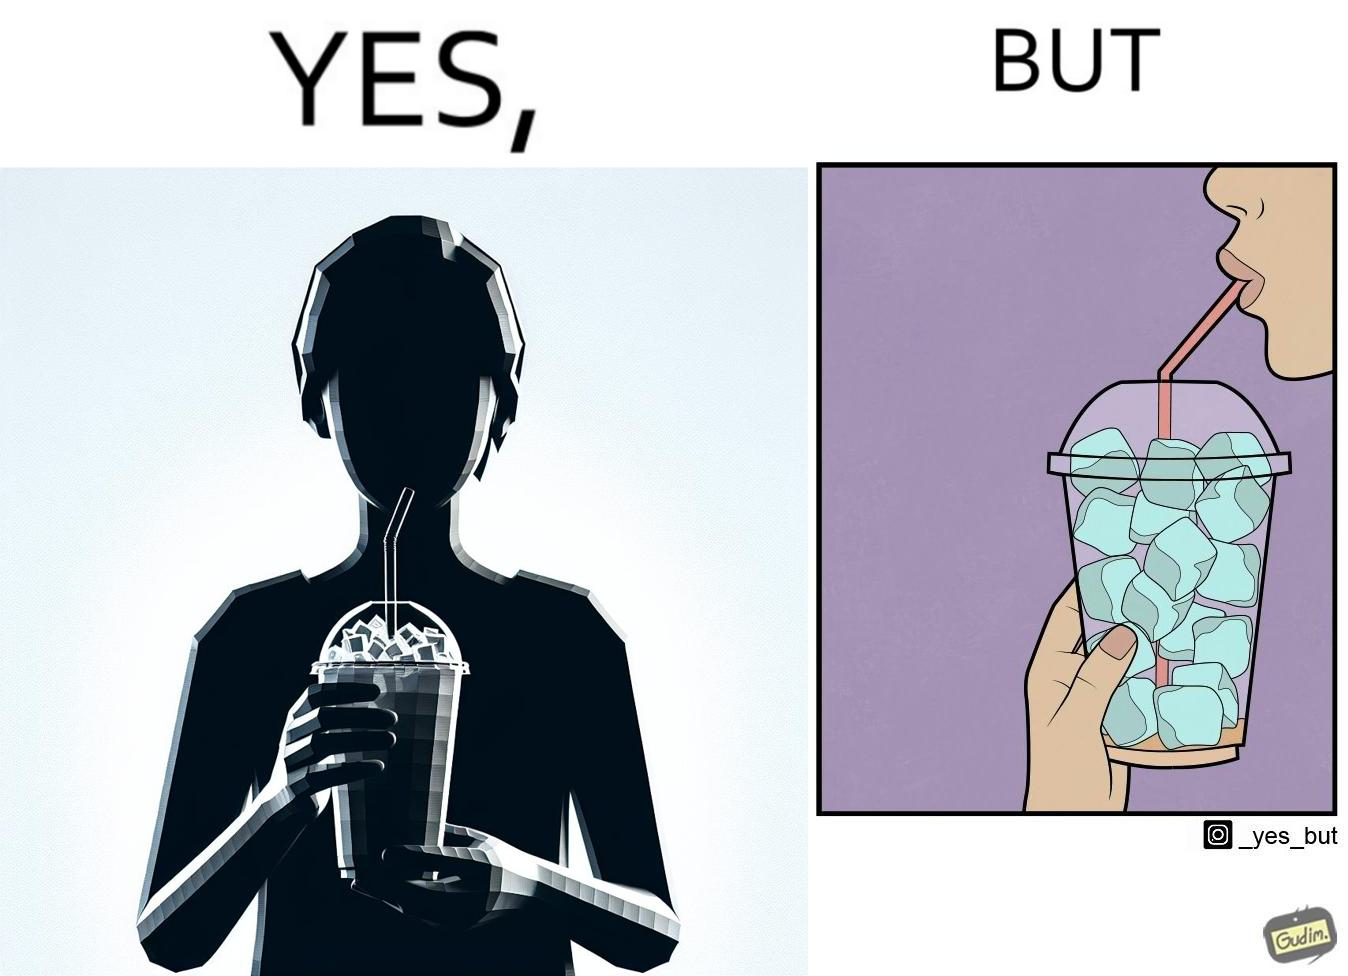Describe the content of this image. The image is funny, as the drink seems to be full to begin with, while most of the volume of the drink is occupied by the ice cubes. 